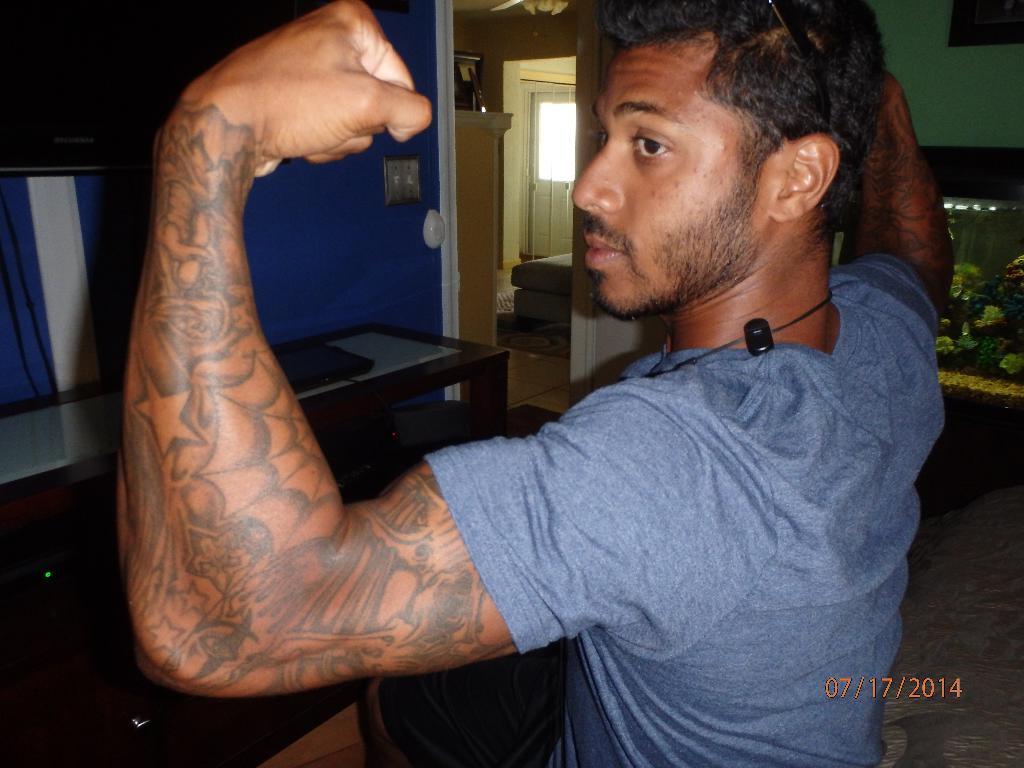Describe this image in one or two sentences. In the image we can see there is a man standing and there are tattoos on his hands. Behind there is a table and there is a house. 